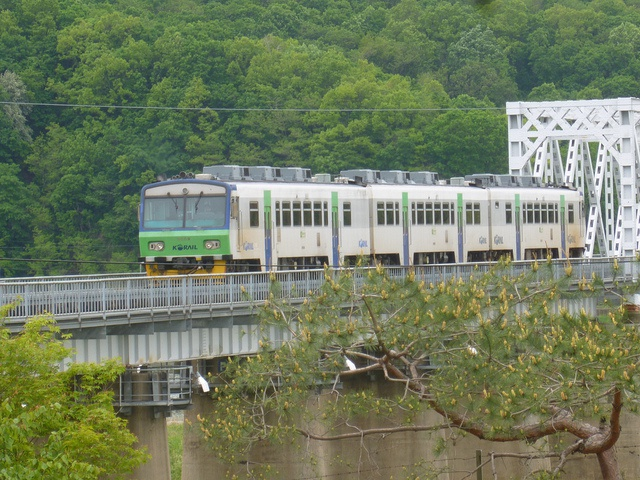Describe the objects in this image and their specific colors. I can see a train in teal, lightgray, darkgray, and gray tones in this image. 